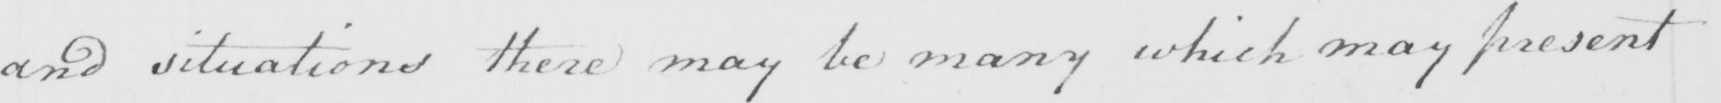What does this handwritten line say? and situations there may be many which may present 